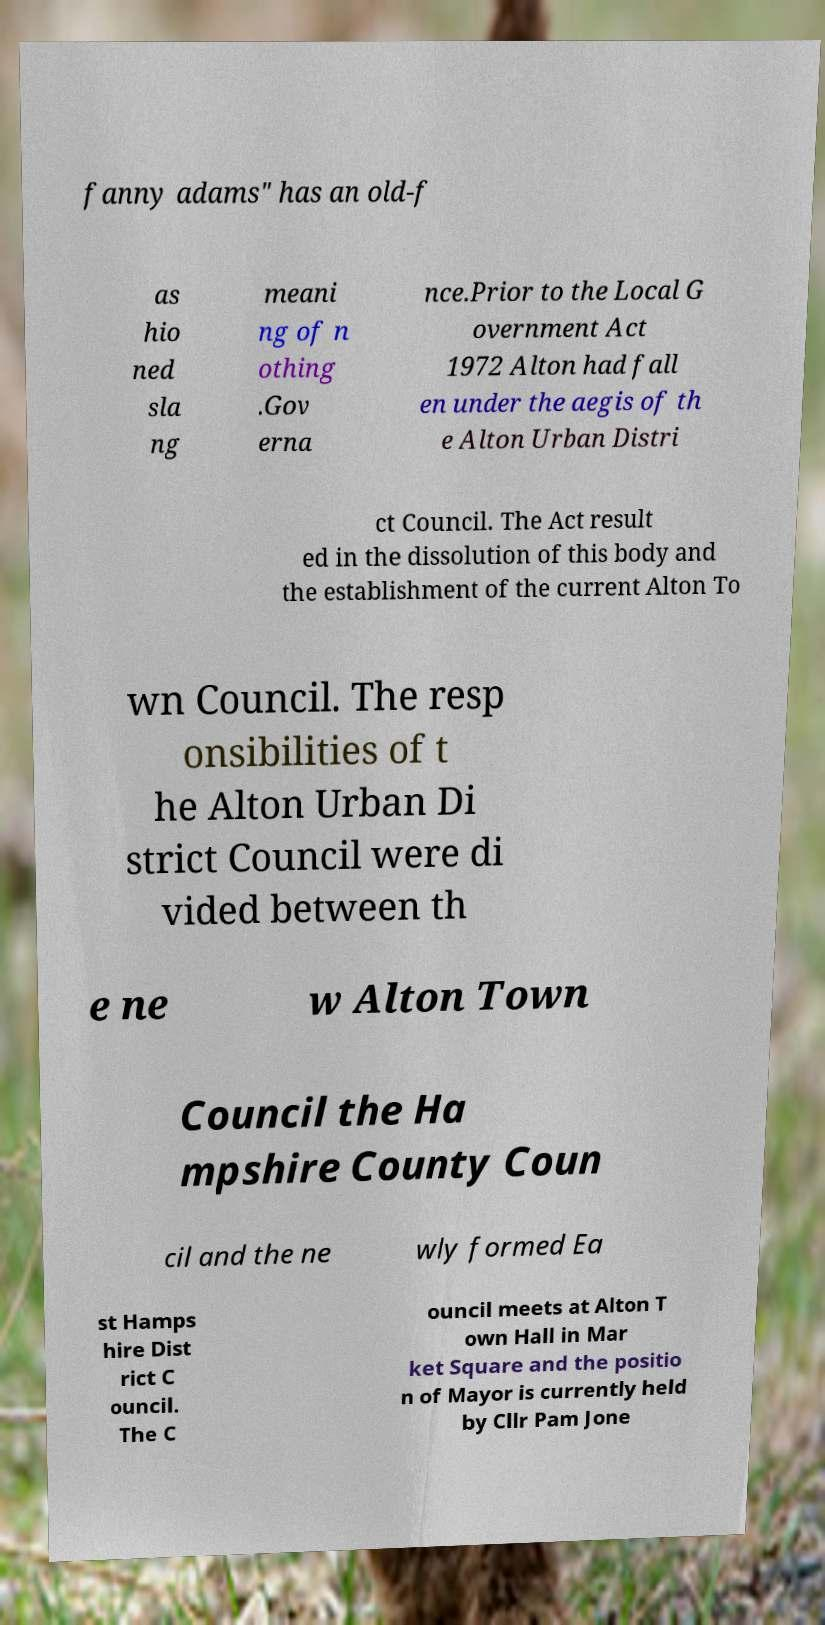Can you accurately transcribe the text from the provided image for me? fanny adams" has an old-f as hio ned sla ng meani ng of n othing .Gov erna nce.Prior to the Local G overnment Act 1972 Alton had fall en under the aegis of th e Alton Urban Distri ct Council. The Act result ed in the dissolution of this body and the establishment of the current Alton To wn Council. The resp onsibilities of t he Alton Urban Di strict Council were di vided between th e ne w Alton Town Council the Ha mpshire County Coun cil and the ne wly formed Ea st Hamps hire Dist rict C ouncil. The C ouncil meets at Alton T own Hall in Mar ket Square and the positio n of Mayor is currently held by Cllr Pam Jone 